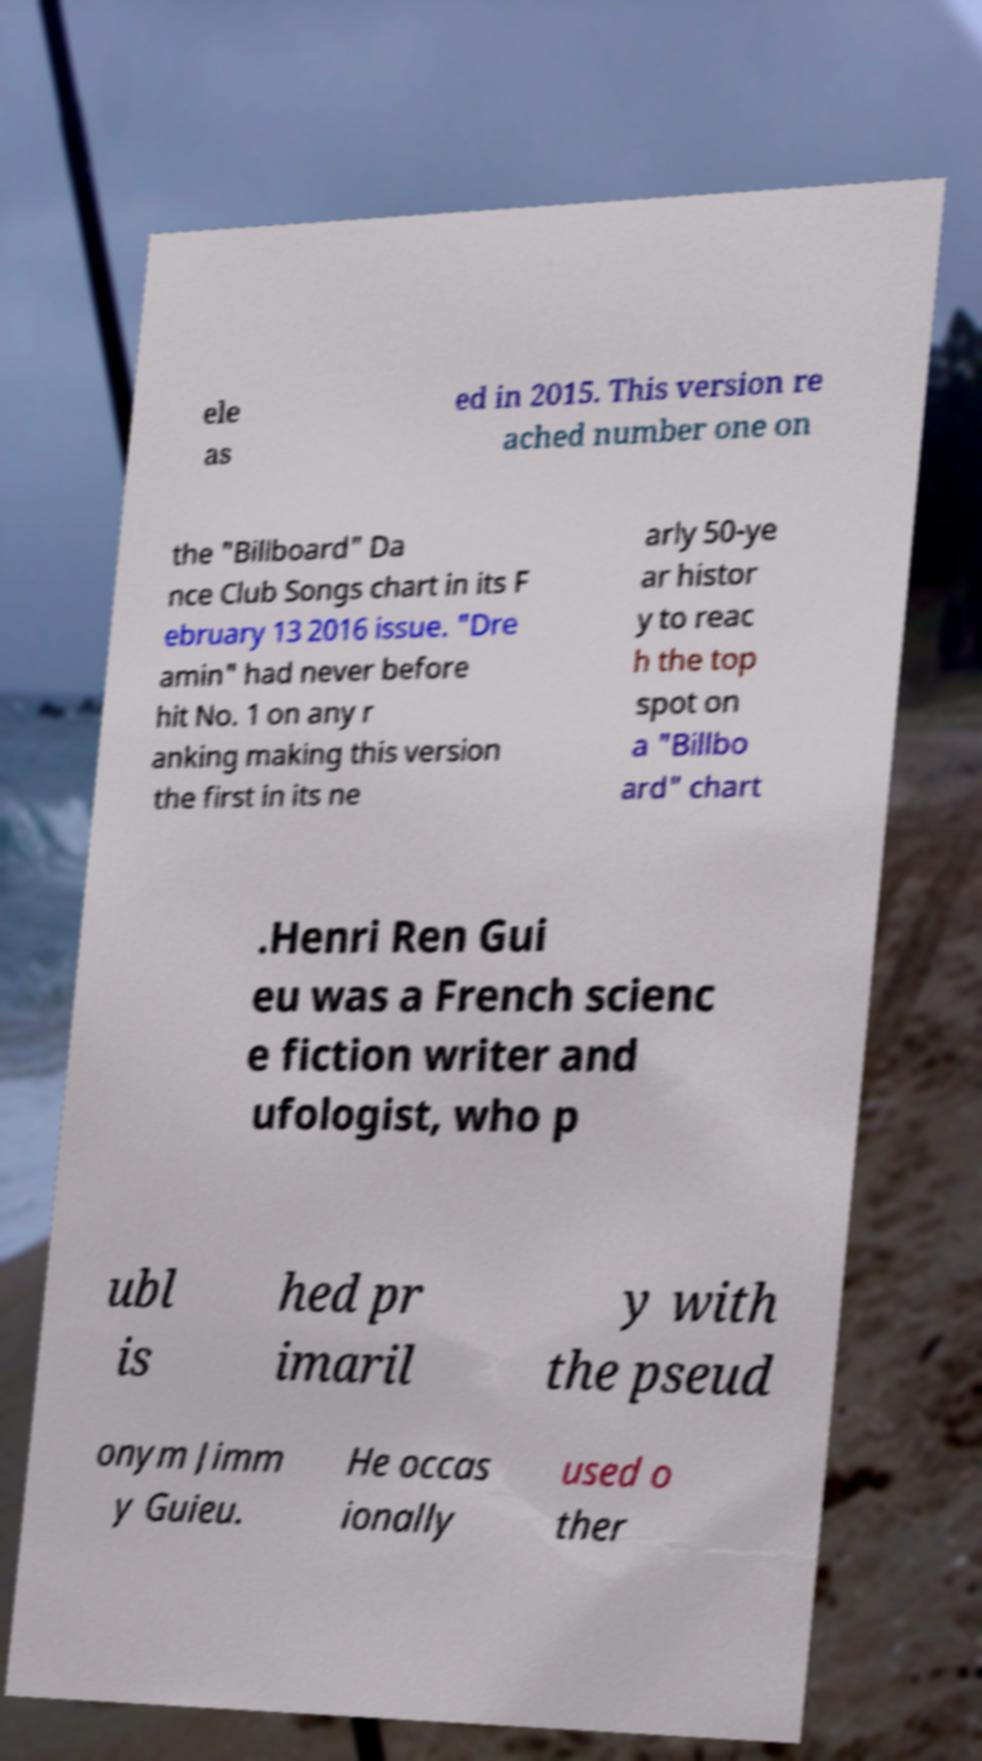I need the written content from this picture converted into text. Can you do that? ele as ed in 2015. This version re ached number one on the "Billboard" Da nce Club Songs chart in its F ebruary 13 2016 issue. "Dre amin" had never before hit No. 1 on any r anking making this version the first in its ne arly 50-ye ar histor y to reac h the top spot on a "Billbo ard" chart .Henri Ren Gui eu was a French scienc e fiction writer and ufologist, who p ubl is hed pr imaril y with the pseud onym Jimm y Guieu. He occas ionally used o ther 